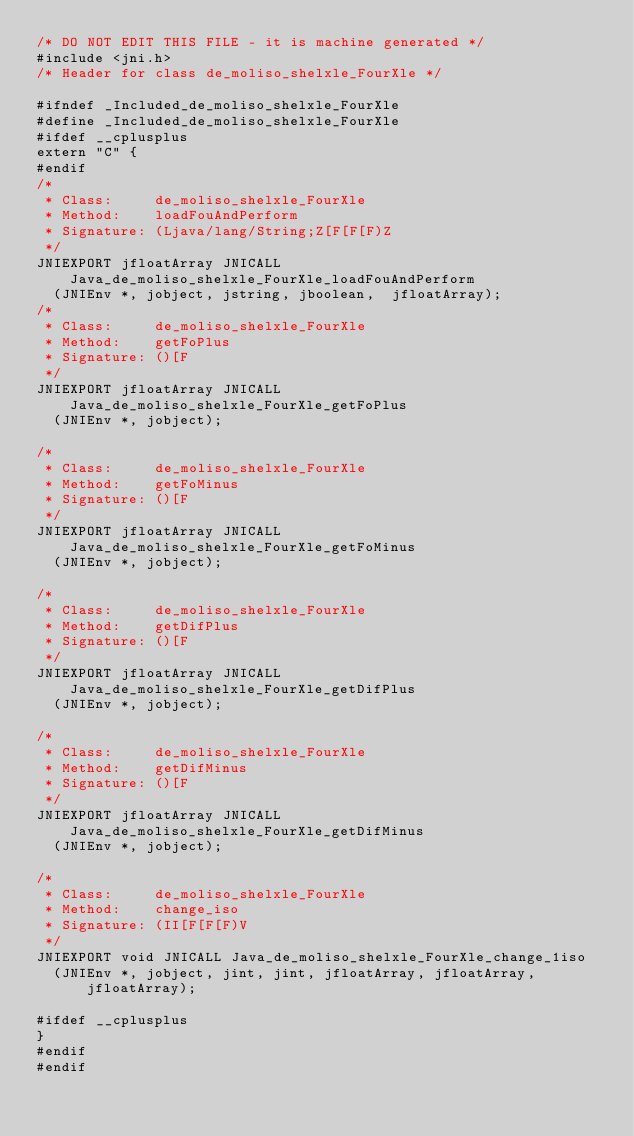<code> <loc_0><loc_0><loc_500><loc_500><_C_>/* DO NOT EDIT THIS FILE - it is machine generated */
#include <jni.h>
/* Header for class de_moliso_shelxle_FourXle */

#ifndef _Included_de_moliso_shelxle_FourXle
#define _Included_de_moliso_shelxle_FourXle
#ifdef __cplusplus
extern "C" {
#endif
/*
 * Class:     de_moliso_shelxle_FourXle
 * Method:    loadFouAndPerform
 * Signature: (Ljava/lang/String;Z[F[F[F)Z
 */
JNIEXPORT jfloatArray JNICALL Java_de_moliso_shelxle_FourXle_loadFouAndPerform
  (JNIEnv *, jobject, jstring, jboolean,  jfloatArray);
/*
 * Class:     de_moliso_shelxle_FourXle
 * Method:    getFoPlus
 * Signature: ()[F
 */
JNIEXPORT jfloatArray JNICALL Java_de_moliso_shelxle_FourXle_getFoPlus
  (JNIEnv *, jobject);

/*
 * Class:     de_moliso_shelxle_FourXle
 * Method:    getFoMinus
 * Signature: ()[F
 */
JNIEXPORT jfloatArray JNICALL Java_de_moliso_shelxle_FourXle_getFoMinus
  (JNIEnv *, jobject);

/*
 * Class:     de_moliso_shelxle_FourXle
 * Method:    getDifPlus
 * Signature: ()[F
 */
JNIEXPORT jfloatArray JNICALL Java_de_moliso_shelxle_FourXle_getDifPlus
  (JNIEnv *, jobject);

/*
 * Class:     de_moliso_shelxle_FourXle
 * Method:    getDifMinus
 * Signature: ()[F
 */
JNIEXPORT jfloatArray JNICALL Java_de_moliso_shelxle_FourXle_getDifMinus
  (JNIEnv *, jobject);

/*
 * Class:     de_moliso_shelxle_FourXle
 * Method:    change_iso
 * Signature: (II[F[F[F)V
 */
JNIEXPORT void JNICALL Java_de_moliso_shelxle_FourXle_change_1iso
  (JNIEnv *, jobject, jint, jint, jfloatArray, jfloatArray, jfloatArray);

#ifdef __cplusplus
}
#endif
#endif
</code> 